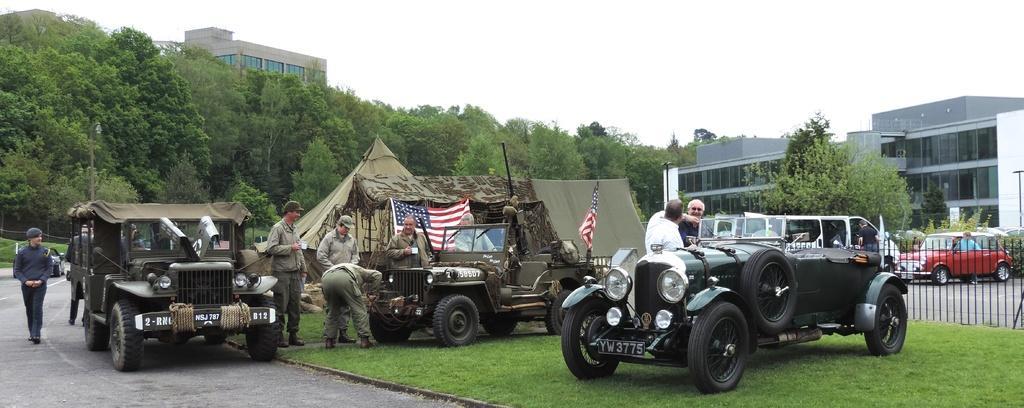Can you describe this image briefly? In the foreground, I can see vehicles, tents, fence and a group of people on grass. In the background, I can see flags, buildings, trees and the sky. This image is taken, maybe during a day. 